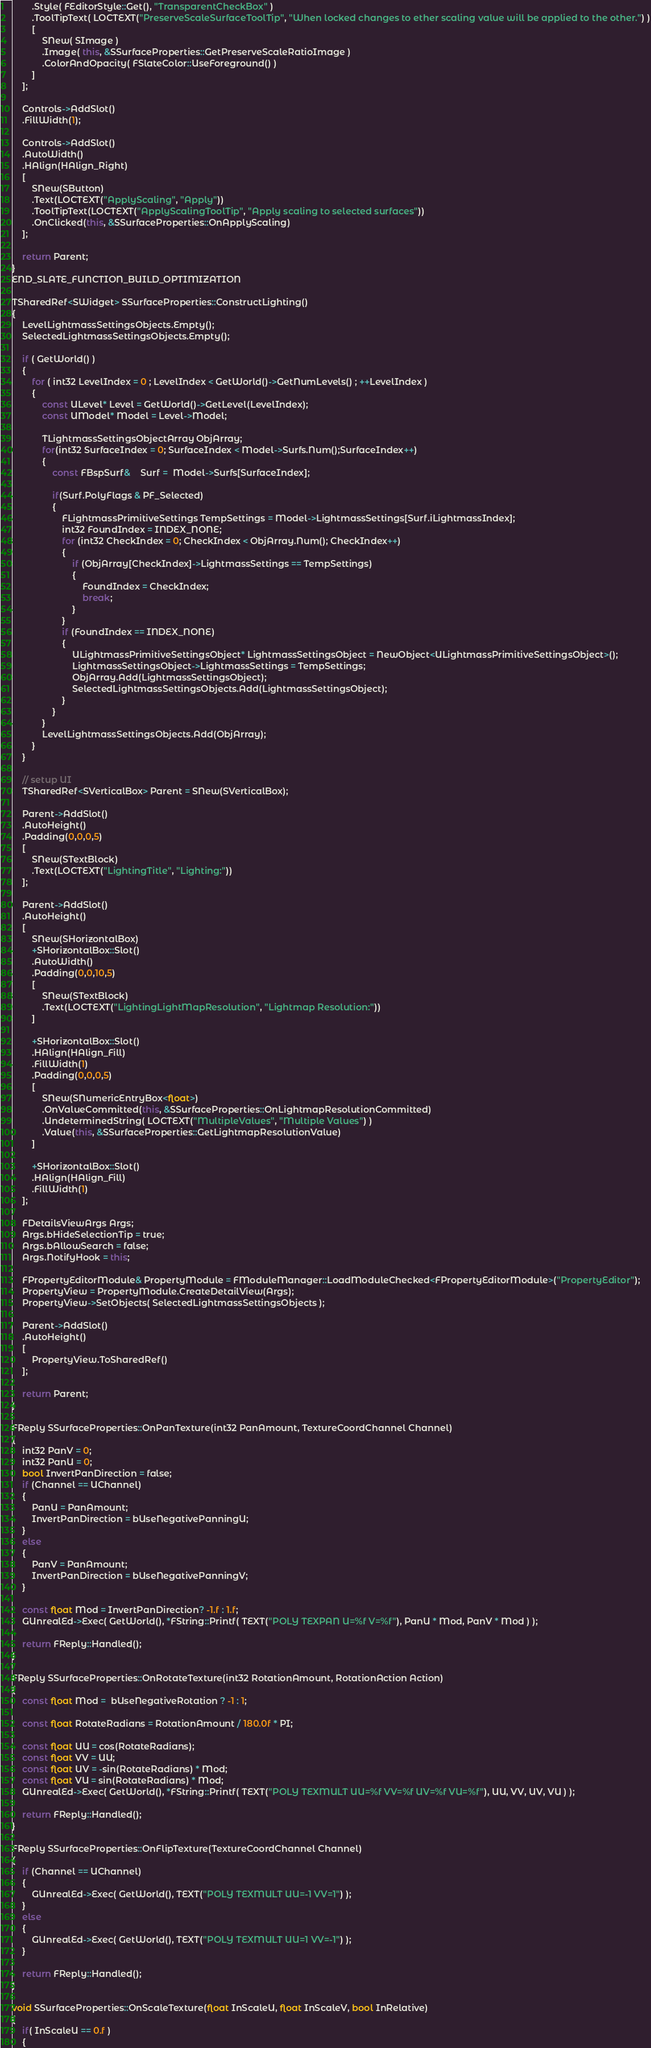<code> <loc_0><loc_0><loc_500><loc_500><_C++_>		.Style( FEditorStyle::Get(), "TransparentCheckBox" )
		.ToolTipText( LOCTEXT("PreserveScaleSurfaceToolTip", "When locked changes to ether scaling value will be applied to the other.") )
		[
			SNew( SImage )
			.Image( this, &SSurfaceProperties::GetPreserveScaleRatioImage )
			.ColorAndOpacity( FSlateColor::UseForeground() )
		]
	];

	Controls->AddSlot()
	.FillWidth(1);

	Controls->AddSlot()
	.AutoWidth()
	.HAlign(HAlign_Right)
	[
		SNew(SButton)
		.Text(LOCTEXT("ApplyScaling", "Apply"))
		.ToolTipText(LOCTEXT("ApplyScalingToolTip", "Apply scaling to selected surfaces"))
		.OnClicked(this, &SSurfaceProperties::OnApplyScaling)
	];

	return Parent;
}
END_SLATE_FUNCTION_BUILD_OPTIMIZATION

TSharedRef<SWidget> SSurfaceProperties::ConstructLighting()
{
	LevelLightmassSettingsObjects.Empty();
	SelectedLightmassSettingsObjects.Empty();
	
	if ( GetWorld() )
	{
		for ( int32 LevelIndex = 0 ; LevelIndex < GetWorld()->GetNumLevels() ; ++LevelIndex )
		{
			const ULevel* Level = GetWorld()->GetLevel(LevelIndex);
			const UModel* Model = Level->Model;

			TLightmassSettingsObjectArray ObjArray;
			for(int32 SurfaceIndex = 0; SurfaceIndex < Model->Surfs.Num();SurfaceIndex++)
			{
				const FBspSurf&	Surf =  Model->Surfs[SurfaceIndex];

				if(Surf.PolyFlags & PF_Selected)
				{
					FLightmassPrimitiveSettings TempSettings = Model->LightmassSettings[Surf.iLightmassIndex];
					int32 FoundIndex = INDEX_NONE;
					for (int32 CheckIndex = 0; CheckIndex < ObjArray.Num(); CheckIndex++)
					{
						if (ObjArray[CheckIndex]->LightmassSettings == TempSettings)
						{
							FoundIndex = CheckIndex;
							break;
						}
					}
					if (FoundIndex == INDEX_NONE)
					{
						ULightmassPrimitiveSettingsObject* LightmassSettingsObject = NewObject<ULightmassPrimitiveSettingsObject>();
						LightmassSettingsObject->LightmassSettings = TempSettings;
						ObjArray.Add(LightmassSettingsObject);
						SelectedLightmassSettingsObjects.Add(LightmassSettingsObject);
					}
				}
			}
			LevelLightmassSettingsObjects.Add(ObjArray);
		}
	}

	// setup UI
	TSharedRef<SVerticalBox> Parent = SNew(SVerticalBox);

	Parent->AddSlot()
	.AutoHeight()
	.Padding(0,0,0,5)
	[
		SNew(STextBlock)
		.Text(LOCTEXT("LightingTitle", "Lighting:"))
	];

	Parent->AddSlot()
	.AutoHeight()
	[
		SNew(SHorizontalBox)
		+SHorizontalBox::Slot()
		.AutoWidth()
		.Padding(0,0,10,5)
		[
			SNew(STextBlock)
			.Text(LOCTEXT("LightingLightMapResolution", "Lightmap Resolution:"))
		]

		+SHorizontalBox::Slot()
		.HAlign(HAlign_Fill)
		.FillWidth(1)
		.Padding(0,0,0,5)
		[
			SNew(SNumericEntryBox<float>)
			.OnValueCommitted(this, &SSurfaceProperties::OnLightmapResolutionCommitted)
			.UndeterminedString( LOCTEXT("MultipleValues", "Multiple Values") )
			.Value(this, &SSurfaceProperties::GetLightmapResolutionValue)
		]

		+SHorizontalBox::Slot()
		.HAlign(HAlign_Fill)
		.FillWidth(1)
	];

	FDetailsViewArgs Args;
	Args.bHideSelectionTip = true;
	Args.bAllowSearch = false;
	Args.NotifyHook = this;

	FPropertyEditorModule& PropertyModule = FModuleManager::LoadModuleChecked<FPropertyEditorModule>("PropertyEditor");
	PropertyView = PropertyModule.CreateDetailView(Args);
	PropertyView->SetObjects( SelectedLightmassSettingsObjects );

	Parent->AddSlot()
	.AutoHeight()
	[
		PropertyView.ToSharedRef()
	];

	return Parent;
}

FReply SSurfaceProperties::OnPanTexture(int32 PanAmount, TextureCoordChannel Channel)
{
	int32 PanV = 0;
	int32 PanU = 0;
	bool InvertPanDirection = false;
	if (Channel == UChannel)
	{
		PanU = PanAmount;
		InvertPanDirection = bUseNegativePanningU;
	}
	else
	{
		PanV = PanAmount;
		InvertPanDirection = bUseNegativePanningV;
	}

	const float Mod = InvertPanDirection? -1.f : 1.f;
	GUnrealEd->Exec( GetWorld(), *FString::Printf( TEXT("POLY TEXPAN U=%f V=%f"), PanU * Mod, PanV * Mod ) );

	return FReply::Handled();
}

FReply SSurfaceProperties::OnRotateTexture(int32 RotationAmount, RotationAction Action)
{
	const float Mod =  bUseNegativeRotation ? -1 : 1;

	const float RotateRadians = RotationAmount / 180.0f * PI;

	const float UU = cos(RotateRadians);
	const float VV = UU;
	const float UV = -sin(RotateRadians) * Mod;
	const float VU = sin(RotateRadians) * Mod;
	GUnrealEd->Exec( GetWorld(), *FString::Printf( TEXT("POLY TEXMULT UU=%f VV=%f UV=%f VU=%f"), UU, VV, UV, VU ) );

	return FReply::Handled();
}

FReply SSurfaceProperties::OnFlipTexture(TextureCoordChannel Channel)
{
	if (Channel == UChannel)
	{
		GUnrealEd->Exec( GetWorld(), TEXT("POLY TEXMULT UU=-1 VV=1") );
	}
	else
	{
		GUnrealEd->Exec( GetWorld(), TEXT("POLY TEXMULT UU=1 VV=-1") );
	}

	return FReply::Handled();
}

void SSurfaceProperties::OnScaleTexture(float InScaleU, float InScaleV, bool InRelative)
{
	if( InScaleU == 0.f )
	{</code> 